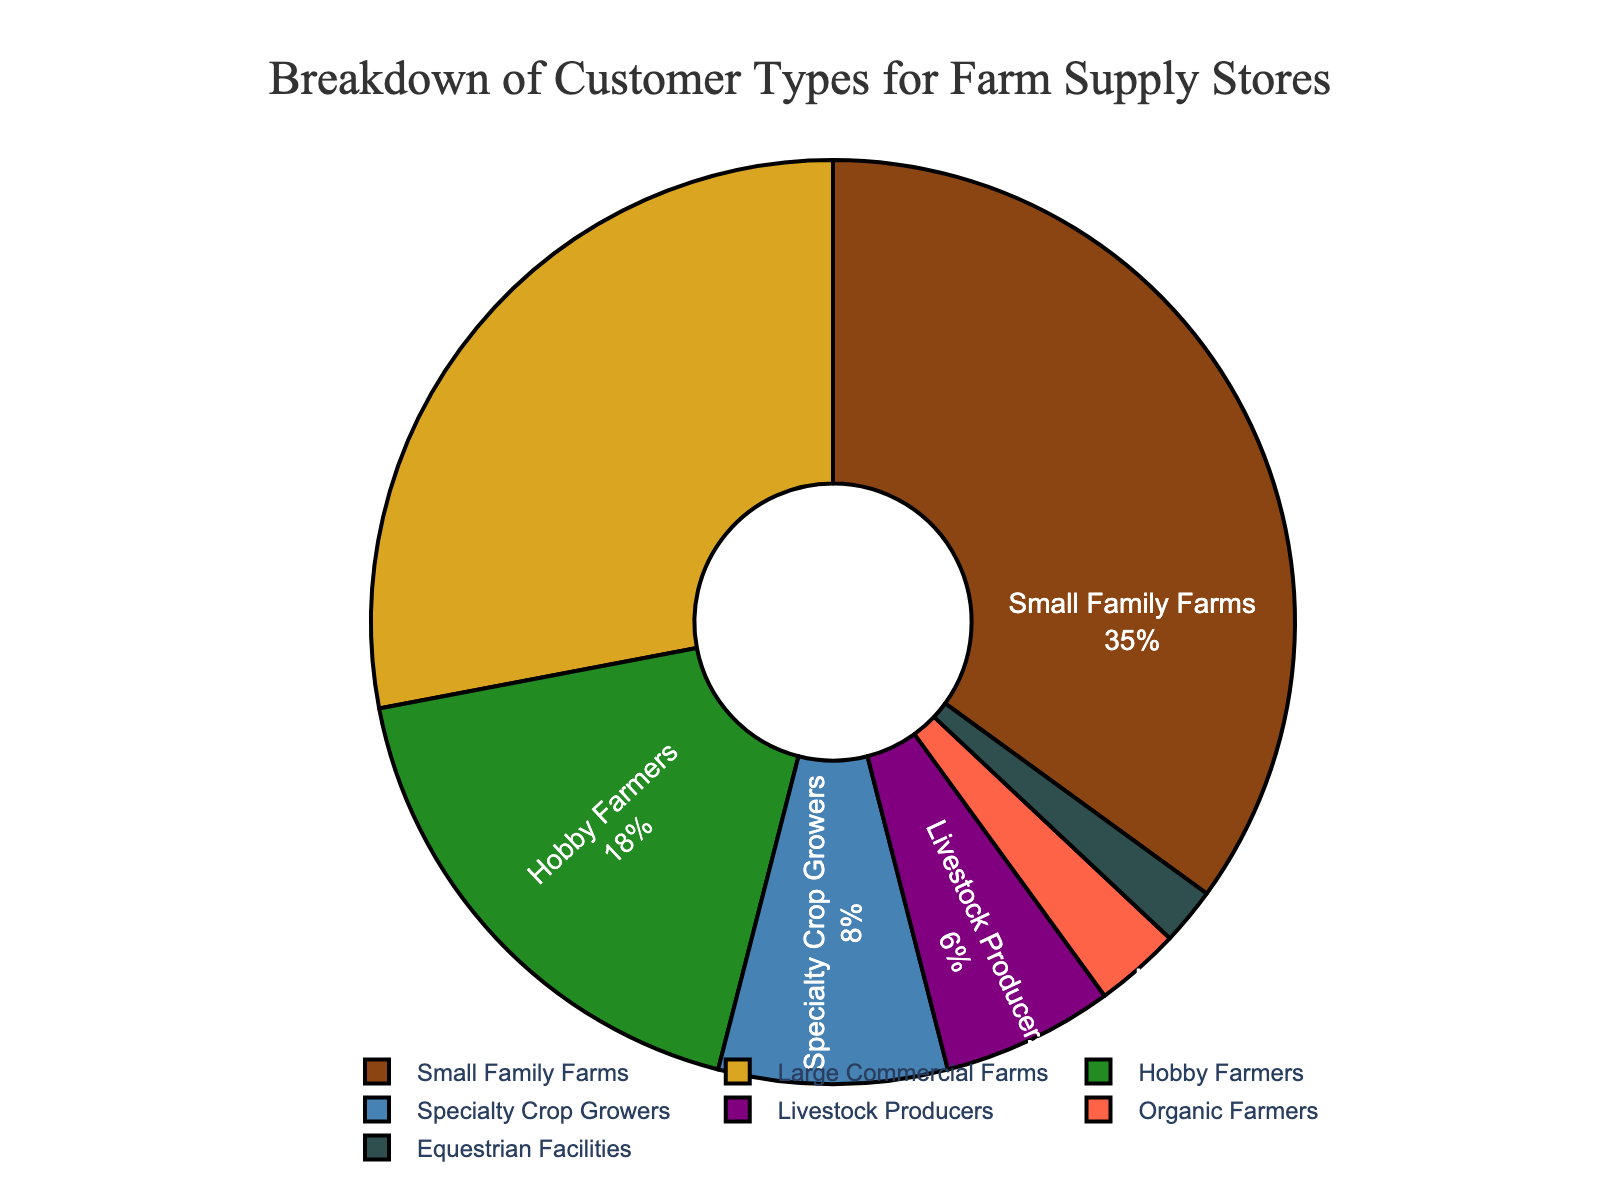Which customer type has the highest percentage? By looking at the pie chart, the segment labeled "Small Family Farms" occupies the largest portion. The percentage for Small Family Farms is 35%.
Answer: Small Family Farms What is the combined percentage of Hobby Farmers and Specialty Crop Growers? Look at the segments for Hobby Farmers and Specialty Crop Growers. Hobby Farmers have 18% and Specialty Crop Growers have 8%. Adding these together, 18% + 8% = 26%.
Answer: 26% How does the percentage of Large Commercial Farms compare to that of Small Family Farms? Large Commercial Farms have a percentage of 28%, while Small Family Farms have 35%. Therefore, Large Commercial Farms have a lower percentage compared to Small Family Farms.
Answer: Lower Which customer type occupies the smallest segment in the chart? By examining the pie chart, the smallest segment is labeled "Equestrian Facilities" with 2%.
Answer: Equestrian Facilities By how much does the percentage of Livestock Producers exceed that of Organic Farmers? Livestock Producers have 6% and Organic Farmers have 3%. The difference is 6% - 3% = 3%.
Answer: 3% What is the total percentage of customer types that have a percentage lower than 10%? Add the percentages of Specialty Crop Growers (8%), Livestock Producers (6%), Organic Farmers (3%), and Equestrian Facilities (2%). 8% + 6% + 3% + 2% = 19%.
Answer: 19% Are there more Hobby Farmers or Livestock Producers? Hobby Farmers have a percentage of 18%, while Livestock Producers have 6%. Hence, there are more Hobby Farmers.
Answer: Hobby Farmers If you were to combine Large Commercial Farms and Organic Farmers, what would their total percentage be? Add the percentages of Large Commercial Farms (28%) and Organic Farmers (3%). 28% + 3% = 31%.
Answer: 31% What is the ratio of Small Family Farms to Large Commercial Farms? Small Family Farms have a percentage of 35% and Large Commercial Farms have 28%. The ratio is 35:28. To simplify, divide both numbers by their GCD, which is 7. The simplified ratio is 5:4.
Answer: 5:4 